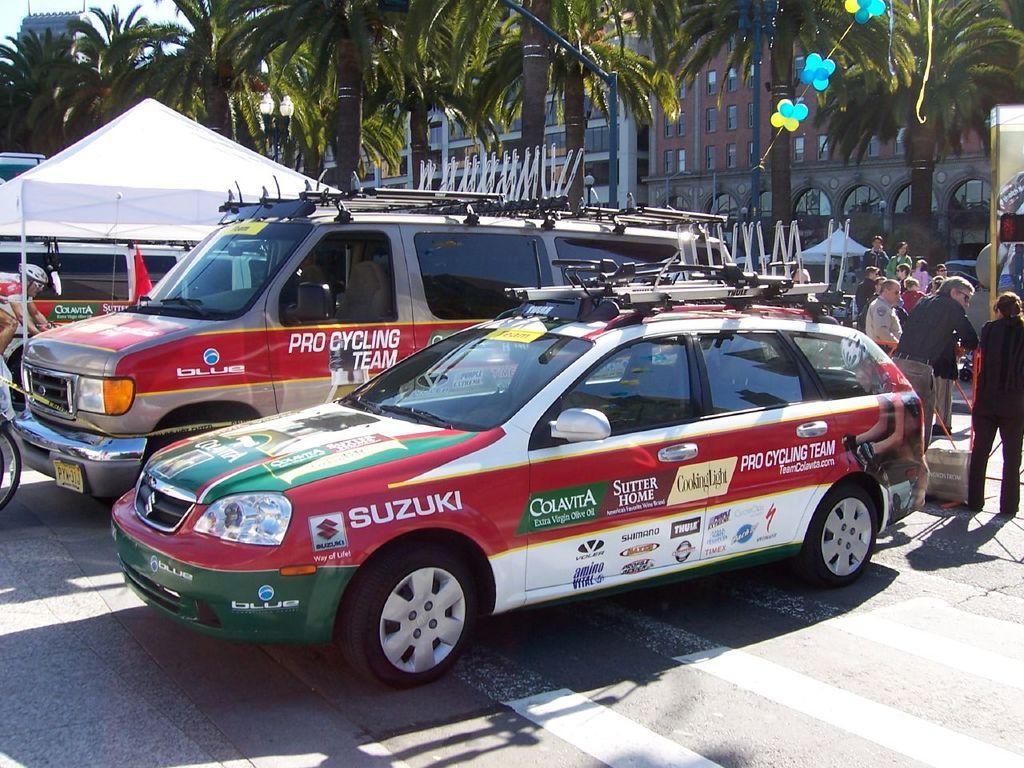Please provide a concise description of this image. In this image there are cars parked on the road, beside the cars there is a tent, behind the cars there are a few people standing, in the background of the image there are trees and buildings. 